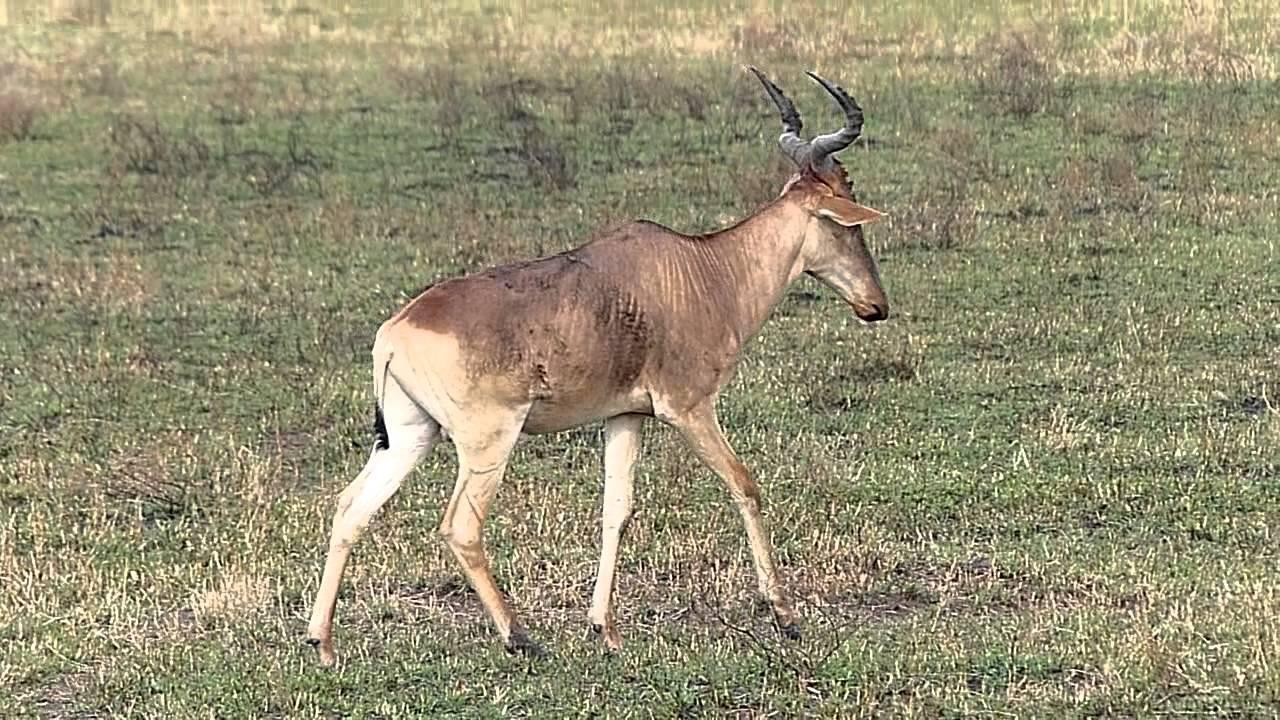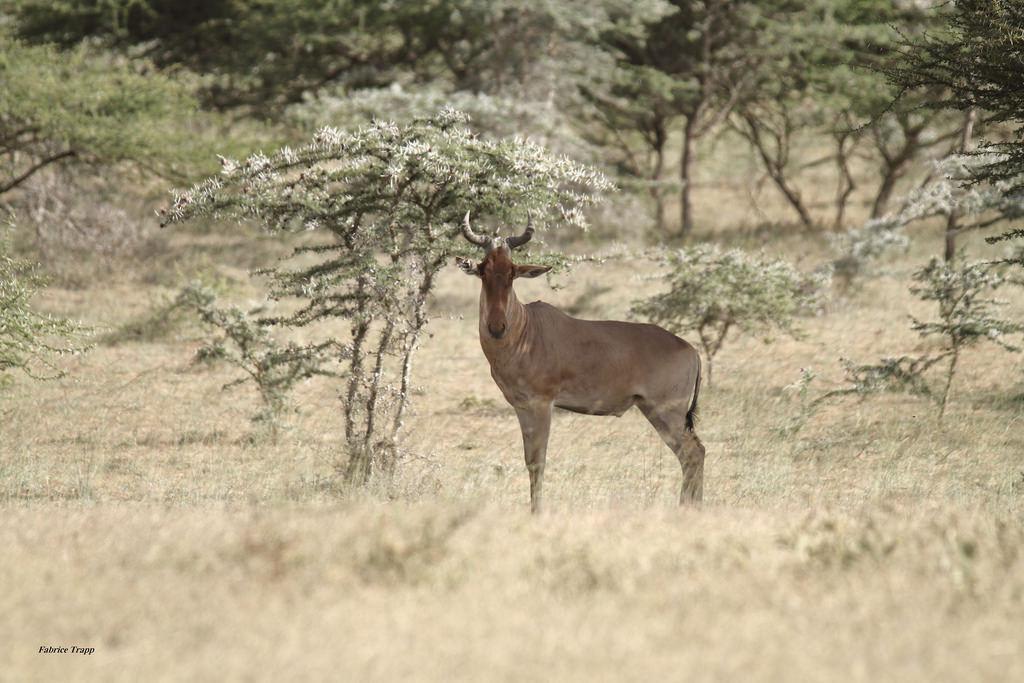The first image is the image on the left, the second image is the image on the right. Evaluate the accuracy of this statement regarding the images: "Each image contains multiple horned animals, and one image includes horned animals facing opposite directions and overlapping.". Is it true? Answer yes or no. No. The first image is the image on the left, the second image is the image on the right. Assess this claim about the two images: "There are exactly two living animals.". Correct or not? Answer yes or no. Yes. 